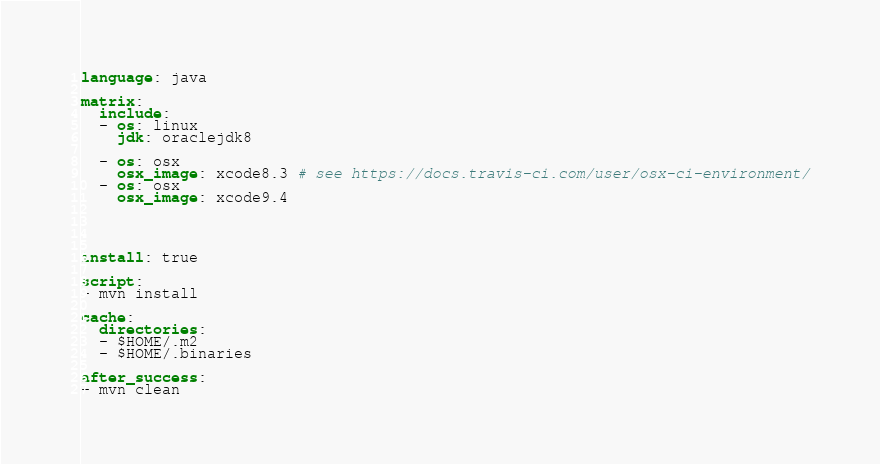<code> <loc_0><loc_0><loc_500><loc_500><_YAML_>language: java

matrix:
  include:
  - os: linux
    jdk: oraclejdk8

  - os: osx
    osx_image: xcode8.3 # see https://docs.travis-ci.com/user/osx-ci-environment/
  - os: osx
    osx_image: xcode9.4




install: true

script:
- mvn install

cache:
  directories:
  - $HOME/.m2
  - $HOME/.binaries

after_success:
- mvn clean</code> 